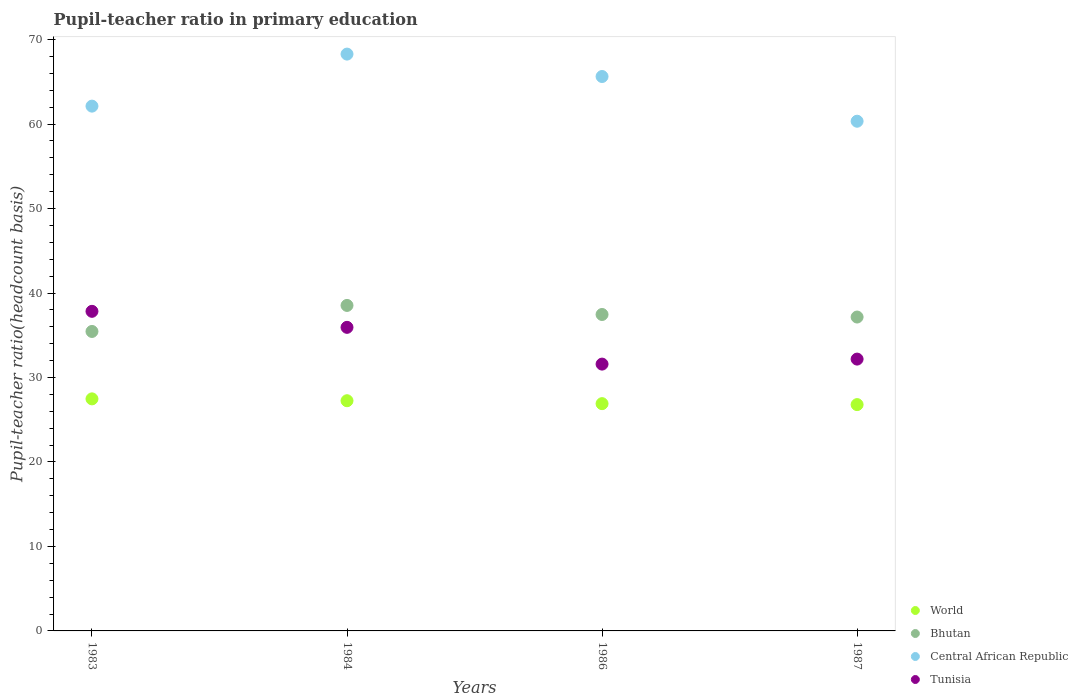What is the pupil-teacher ratio in primary education in Tunisia in 1984?
Provide a short and direct response. 35.94. Across all years, what is the maximum pupil-teacher ratio in primary education in Central African Republic?
Your answer should be compact. 68.29. Across all years, what is the minimum pupil-teacher ratio in primary education in Bhutan?
Your answer should be compact. 35.45. In which year was the pupil-teacher ratio in primary education in World maximum?
Give a very brief answer. 1983. In which year was the pupil-teacher ratio in primary education in World minimum?
Your answer should be compact. 1987. What is the total pupil-teacher ratio in primary education in Tunisia in the graph?
Make the answer very short. 137.54. What is the difference between the pupil-teacher ratio in primary education in Bhutan in 1983 and that in 1984?
Offer a terse response. -3.08. What is the difference between the pupil-teacher ratio in primary education in Tunisia in 1983 and the pupil-teacher ratio in primary education in Central African Republic in 1986?
Keep it short and to the point. -27.8. What is the average pupil-teacher ratio in primary education in Bhutan per year?
Ensure brevity in your answer.  37.15. In the year 1987, what is the difference between the pupil-teacher ratio in primary education in World and pupil-teacher ratio in primary education in Central African Republic?
Give a very brief answer. -33.55. What is the ratio of the pupil-teacher ratio in primary education in Tunisia in 1984 to that in 1986?
Provide a succinct answer. 1.14. Is the pupil-teacher ratio in primary education in World in 1986 less than that in 1987?
Make the answer very short. No. Is the difference between the pupil-teacher ratio in primary education in World in 1984 and 1987 greater than the difference between the pupil-teacher ratio in primary education in Central African Republic in 1984 and 1987?
Provide a succinct answer. No. What is the difference between the highest and the second highest pupil-teacher ratio in primary education in Bhutan?
Make the answer very short. 1.07. What is the difference between the highest and the lowest pupil-teacher ratio in primary education in Bhutan?
Your response must be concise. 3.08. In how many years, is the pupil-teacher ratio in primary education in World greater than the average pupil-teacher ratio in primary education in World taken over all years?
Provide a short and direct response. 2. Is the sum of the pupil-teacher ratio in primary education in World in 1986 and 1987 greater than the maximum pupil-teacher ratio in primary education in Central African Republic across all years?
Offer a very short reply. No. Is it the case that in every year, the sum of the pupil-teacher ratio in primary education in Central African Republic and pupil-teacher ratio in primary education in Bhutan  is greater than the sum of pupil-teacher ratio in primary education in World and pupil-teacher ratio in primary education in Tunisia?
Keep it short and to the point. No. Does the pupil-teacher ratio in primary education in Tunisia monotonically increase over the years?
Make the answer very short. No. What is the difference between two consecutive major ticks on the Y-axis?
Keep it short and to the point. 10. Are the values on the major ticks of Y-axis written in scientific E-notation?
Provide a succinct answer. No. Does the graph contain any zero values?
Provide a short and direct response. No. Does the graph contain grids?
Offer a terse response. No. How many legend labels are there?
Give a very brief answer. 4. How are the legend labels stacked?
Give a very brief answer. Vertical. What is the title of the graph?
Offer a very short reply. Pupil-teacher ratio in primary education. Does "Israel" appear as one of the legend labels in the graph?
Your answer should be very brief. No. What is the label or title of the Y-axis?
Provide a succinct answer. Pupil-teacher ratio(headcount basis). What is the Pupil-teacher ratio(headcount basis) in World in 1983?
Make the answer very short. 27.47. What is the Pupil-teacher ratio(headcount basis) of Bhutan in 1983?
Give a very brief answer. 35.45. What is the Pupil-teacher ratio(headcount basis) in Central African Republic in 1983?
Your answer should be compact. 62.13. What is the Pupil-teacher ratio(headcount basis) in Tunisia in 1983?
Your answer should be very brief. 37.83. What is the Pupil-teacher ratio(headcount basis) of World in 1984?
Your answer should be very brief. 27.25. What is the Pupil-teacher ratio(headcount basis) in Bhutan in 1984?
Make the answer very short. 38.53. What is the Pupil-teacher ratio(headcount basis) of Central African Republic in 1984?
Give a very brief answer. 68.29. What is the Pupil-teacher ratio(headcount basis) of Tunisia in 1984?
Give a very brief answer. 35.94. What is the Pupil-teacher ratio(headcount basis) in World in 1986?
Your answer should be very brief. 26.9. What is the Pupil-teacher ratio(headcount basis) of Bhutan in 1986?
Ensure brevity in your answer.  37.46. What is the Pupil-teacher ratio(headcount basis) in Central African Republic in 1986?
Keep it short and to the point. 65.63. What is the Pupil-teacher ratio(headcount basis) in Tunisia in 1986?
Offer a very short reply. 31.59. What is the Pupil-teacher ratio(headcount basis) in World in 1987?
Give a very brief answer. 26.79. What is the Pupil-teacher ratio(headcount basis) in Bhutan in 1987?
Give a very brief answer. 37.16. What is the Pupil-teacher ratio(headcount basis) of Central African Republic in 1987?
Offer a very short reply. 60.34. What is the Pupil-teacher ratio(headcount basis) of Tunisia in 1987?
Provide a succinct answer. 32.18. Across all years, what is the maximum Pupil-teacher ratio(headcount basis) of World?
Keep it short and to the point. 27.47. Across all years, what is the maximum Pupil-teacher ratio(headcount basis) in Bhutan?
Offer a terse response. 38.53. Across all years, what is the maximum Pupil-teacher ratio(headcount basis) in Central African Republic?
Offer a very short reply. 68.29. Across all years, what is the maximum Pupil-teacher ratio(headcount basis) of Tunisia?
Keep it short and to the point. 37.83. Across all years, what is the minimum Pupil-teacher ratio(headcount basis) of World?
Keep it short and to the point. 26.79. Across all years, what is the minimum Pupil-teacher ratio(headcount basis) of Bhutan?
Give a very brief answer. 35.45. Across all years, what is the minimum Pupil-teacher ratio(headcount basis) of Central African Republic?
Your response must be concise. 60.34. Across all years, what is the minimum Pupil-teacher ratio(headcount basis) in Tunisia?
Provide a succinct answer. 31.59. What is the total Pupil-teacher ratio(headcount basis) of World in the graph?
Your answer should be very brief. 108.42. What is the total Pupil-teacher ratio(headcount basis) in Bhutan in the graph?
Provide a succinct answer. 148.6. What is the total Pupil-teacher ratio(headcount basis) of Central African Republic in the graph?
Provide a succinct answer. 256.38. What is the total Pupil-teacher ratio(headcount basis) in Tunisia in the graph?
Offer a terse response. 137.54. What is the difference between the Pupil-teacher ratio(headcount basis) of World in 1983 and that in 1984?
Offer a very short reply. 0.22. What is the difference between the Pupil-teacher ratio(headcount basis) in Bhutan in 1983 and that in 1984?
Keep it short and to the point. -3.08. What is the difference between the Pupil-teacher ratio(headcount basis) in Central African Republic in 1983 and that in 1984?
Your answer should be very brief. -6.16. What is the difference between the Pupil-teacher ratio(headcount basis) in Tunisia in 1983 and that in 1984?
Your answer should be compact. 1.9. What is the difference between the Pupil-teacher ratio(headcount basis) of World in 1983 and that in 1986?
Your answer should be very brief. 0.57. What is the difference between the Pupil-teacher ratio(headcount basis) of Bhutan in 1983 and that in 1986?
Give a very brief answer. -2.01. What is the difference between the Pupil-teacher ratio(headcount basis) of Central African Republic in 1983 and that in 1986?
Give a very brief answer. -3.51. What is the difference between the Pupil-teacher ratio(headcount basis) in Tunisia in 1983 and that in 1986?
Give a very brief answer. 6.25. What is the difference between the Pupil-teacher ratio(headcount basis) of World in 1983 and that in 1987?
Provide a succinct answer. 0.68. What is the difference between the Pupil-teacher ratio(headcount basis) of Bhutan in 1983 and that in 1987?
Offer a very short reply. -1.71. What is the difference between the Pupil-teacher ratio(headcount basis) in Central African Republic in 1983 and that in 1987?
Your answer should be very brief. 1.79. What is the difference between the Pupil-teacher ratio(headcount basis) of Tunisia in 1983 and that in 1987?
Keep it short and to the point. 5.65. What is the difference between the Pupil-teacher ratio(headcount basis) in World in 1984 and that in 1986?
Give a very brief answer. 0.35. What is the difference between the Pupil-teacher ratio(headcount basis) in Bhutan in 1984 and that in 1986?
Offer a terse response. 1.07. What is the difference between the Pupil-teacher ratio(headcount basis) of Central African Republic in 1984 and that in 1986?
Provide a short and direct response. 2.65. What is the difference between the Pupil-teacher ratio(headcount basis) in Tunisia in 1984 and that in 1986?
Your response must be concise. 4.35. What is the difference between the Pupil-teacher ratio(headcount basis) of World in 1984 and that in 1987?
Your response must be concise. 0.46. What is the difference between the Pupil-teacher ratio(headcount basis) in Bhutan in 1984 and that in 1987?
Offer a terse response. 1.37. What is the difference between the Pupil-teacher ratio(headcount basis) of Central African Republic in 1984 and that in 1987?
Your answer should be compact. 7.95. What is the difference between the Pupil-teacher ratio(headcount basis) in Tunisia in 1984 and that in 1987?
Your answer should be very brief. 3.76. What is the difference between the Pupil-teacher ratio(headcount basis) in World in 1986 and that in 1987?
Give a very brief answer. 0.11. What is the difference between the Pupil-teacher ratio(headcount basis) of Bhutan in 1986 and that in 1987?
Keep it short and to the point. 0.3. What is the difference between the Pupil-teacher ratio(headcount basis) in Central African Republic in 1986 and that in 1987?
Your answer should be compact. 5.29. What is the difference between the Pupil-teacher ratio(headcount basis) in Tunisia in 1986 and that in 1987?
Keep it short and to the point. -0.59. What is the difference between the Pupil-teacher ratio(headcount basis) of World in 1983 and the Pupil-teacher ratio(headcount basis) of Bhutan in 1984?
Give a very brief answer. -11.06. What is the difference between the Pupil-teacher ratio(headcount basis) of World in 1983 and the Pupil-teacher ratio(headcount basis) of Central African Republic in 1984?
Make the answer very short. -40.81. What is the difference between the Pupil-teacher ratio(headcount basis) of World in 1983 and the Pupil-teacher ratio(headcount basis) of Tunisia in 1984?
Keep it short and to the point. -8.47. What is the difference between the Pupil-teacher ratio(headcount basis) of Bhutan in 1983 and the Pupil-teacher ratio(headcount basis) of Central African Republic in 1984?
Ensure brevity in your answer.  -32.83. What is the difference between the Pupil-teacher ratio(headcount basis) of Bhutan in 1983 and the Pupil-teacher ratio(headcount basis) of Tunisia in 1984?
Provide a short and direct response. -0.49. What is the difference between the Pupil-teacher ratio(headcount basis) in Central African Republic in 1983 and the Pupil-teacher ratio(headcount basis) in Tunisia in 1984?
Give a very brief answer. 26.19. What is the difference between the Pupil-teacher ratio(headcount basis) in World in 1983 and the Pupil-teacher ratio(headcount basis) in Bhutan in 1986?
Offer a very short reply. -9.99. What is the difference between the Pupil-teacher ratio(headcount basis) in World in 1983 and the Pupil-teacher ratio(headcount basis) in Central African Republic in 1986?
Provide a short and direct response. -38.16. What is the difference between the Pupil-teacher ratio(headcount basis) in World in 1983 and the Pupil-teacher ratio(headcount basis) in Tunisia in 1986?
Offer a very short reply. -4.12. What is the difference between the Pupil-teacher ratio(headcount basis) in Bhutan in 1983 and the Pupil-teacher ratio(headcount basis) in Central African Republic in 1986?
Keep it short and to the point. -30.18. What is the difference between the Pupil-teacher ratio(headcount basis) in Bhutan in 1983 and the Pupil-teacher ratio(headcount basis) in Tunisia in 1986?
Provide a short and direct response. 3.86. What is the difference between the Pupil-teacher ratio(headcount basis) of Central African Republic in 1983 and the Pupil-teacher ratio(headcount basis) of Tunisia in 1986?
Offer a terse response. 30.54. What is the difference between the Pupil-teacher ratio(headcount basis) of World in 1983 and the Pupil-teacher ratio(headcount basis) of Bhutan in 1987?
Your answer should be very brief. -9.69. What is the difference between the Pupil-teacher ratio(headcount basis) of World in 1983 and the Pupil-teacher ratio(headcount basis) of Central African Republic in 1987?
Ensure brevity in your answer.  -32.87. What is the difference between the Pupil-teacher ratio(headcount basis) in World in 1983 and the Pupil-teacher ratio(headcount basis) in Tunisia in 1987?
Give a very brief answer. -4.71. What is the difference between the Pupil-teacher ratio(headcount basis) in Bhutan in 1983 and the Pupil-teacher ratio(headcount basis) in Central African Republic in 1987?
Offer a very short reply. -24.89. What is the difference between the Pupil-teacher ratio(headcount basis) in Bhutan in 1983 and the Pupil-teacher ratio(headcount basis) in Tunisia in 1987?
Keep it short and to the point. 3.27. What is the difference between the Pupil-teacher ratio(headcount basis) of Central African Republic in 1983 and the Pupil-teacher ratio(headcount basis) of Tunisia in 1987?
Offer a terse response. 29.95. What is the difference between the Pupil-teacher ratio(headcount basis) in World in 1984 and the Pupil-teacher ratio(headcount basis) in Bhutan in 1986?
Your answer should be very brief. -10.21. What is the difference between the Pupil-teacher ratio(headcount basis) of World in 1984 and the Pupil-teacher ratio(headcount basis) of Central African Republic in 1986?
Your answer should be very brief. -38.38. What is the difference between the Pupil-teacher ratio(headcount basis) in World in 1984 and the Pupil-teacher ratio(headcount basis) in Tunisia in 1986?
Ensure brevity in your answer.  -4.34. What is the difference between the Pupil-teacher ratio(headcount basis) in Bhutan in 1984 and the Pupil-teacher ratio(headcount basis) in Central African Republic in 1986?
Provide a short and direct response. -27.1. What is the difference between the Pupil-teacher ratio(headcount basis) of Bhutan in 1984 and the Pupil-teacher ratio(headcount basis) of Tunisia in 1986?
Make the answer very short. 6.95. What is the difference between the Pupil-teacher ratio(headcount basis) of Central African Republic in 1984 and the Pupil-teacher ratio(headcount basis) of Tunisia in 1986?
Offer a very short reply. 36.7. What is the difference between the Pupil-teacher ratio(headcount basis) of World in 1984 and the Pupil-teacher ratio(headcount basis) of Bhutan in 1987?
Provide a short and direct response. -9.91. What is the difference between the Pupil-teacher ratio(headcount basis) of World in 1984 and the Pupil-teacher ratio(headcount basis) of Central African Republic in 1987?
Provide a succinct answer. -33.09. What is the difference between the Pupil-teacher ratio(headcount basis) in World in 1984 and the Pupil-teacher ratio(headcount basis) in Tunisia in 1987?
Provide a succinct answer. -4.93. What is the difference between the Pupil-teacher ratio(headcount basis) of Bhutan in 1984 and the Pupil-teacher ratio(headcount basis) of Central African Republic in 1987?
Keep it short and to the point. -21.81. What is the difference between the Pupil-teacher ratio(headcount basis) in Bhutan in 1984 and the Pupil-teacher ratio(headcount basis) in Tunisia in 1987?
Provide a succinct answer. 6.35. What is the difference between the Pupil-teacher ratio(headcount basis) of Central African Republic in 1984 and the Pupil-teacher ratio(headcount basis) of Tunisia in 1987?
Provide a short and direct response. 36.11. What is the difference between the Pupil-teacher ratio(headcount basis) in World in 1986 and the Pupil-teacher ratio(headcount basis) in Bhutan in 1987?
Offer a terse response. -10.25. What is the difference between the Pupil-teacher ratio(headcount basis) in World in 1986 and the Pupil-teacher ratio(headcount basis) in Central African Republic in 1987?
Make the answer very short. -33.43. What is the difference between the Pupil-teacher ratio(headcount basis) in World in 1986 and the Pupil-teacher ratio(headcount basis) in Tunisia in 1987?
Your response must be concise. -5.27. What is the difference between the Pupil-teacher ratio(headcount basis) in Bhutan in 1986 and the Pupil-teacher ratio(headcount basis) in Central African Republic in 1987?
Offer a terse response. -22.88. What is the difference between the Pupil-teacher ratio(headcount basis) in Bhutan in 1986 and the Pupil-teacher ratio(headcount basis) in Tunisia in 1987?
Make the answer very short. 5.28. What is the difference between the Pupil-teacher ratio(headcount basis) in Central African Republic in 1986 and the Pupil-teacher ratio(headcount basis) in Tunisia in 1987?
Offer a very short reply. 33.45. What is the average Pupil-teacher ratio(headcount basis) in World per year?
Keep it short and to the point. 27.1. What is the average Pupil-teacher ratio(headcount basis) of Bhutan per year?
Keep it short and to the point. 37.15. What is the average Pupil-teacher ratio(headcount basis) of Central African Republic per year?
Ensure brevity in your answer.  64.1. What is the average Pupil-teacher ratio(headcount basis) of Tunisia per year?
Your response must be concise. 34.38. In the year 1983, what is the difference between the Pupil-teacher ratio(headcount basis) in World and Pupil-teacher ratio(headcount basis) in Bhutan?
Give a very brief answer. -7.98. In the year 1983, what is the difference between the Pupil-teacher ratio(headcount basis) of World and Pupil-teacher ratio(headcount basis) of Central African Republic?
Ensure brevity in your answer.  -34.65. In the year 1983, what is the difference between the Pupil-teacher ratio(headcount basis) of World and Pupil-teacher ratio(headcount basis) of Tunisia?
Keep it short and to the point. -10.36. In the year 1983, what is the difference between the Pupil-teacher ratio(headcount basis) in Bhutan and Pupil-teacher ratio(headcount basis) in Central African Republic?
Your answer should be very brief. -26.67. In the year 1983, what is the difference between the Pupil-teacher ratio(headcount basis) in Bhutan and Pupil-teacher ratio(headcount basis) in Tunisia?
Your answer should be compact. -2.38. In the year 1983, what is the difference between the Pupil-teacher ratio(headcount basis) of Central African Republic and Pupil-teacher ratio(headcount basis) of Tunisia?
Provide a succinct answer. 24.29. In the year 1984, what is the difference between the Pupil-teacher ratio(headcount basis) of World and Pupil-teacher ratio(headcount basis) of Bhutan?
Make the answer very short. -11.28. In the year 1984, what is the difference between the Pupil-teacher ratio(headcount basis) in World and Pupil-teacher ratio(headcount basis) in Central African Republic?
Ensure brevity in your answer.  -41.04. In the year 1984, what is the difference between the Pupil-teacher ratio(headcount basis) of World and Pupil-teacher ratio(headcount basis) of Tunisia?
Provide a succinct answer. -8.69. In the year 1984, what is the difference between the Pupil-teacher ratio(headcount basis) in Bhutan and Pupil-teacher ratio(headcount basis) in Central African Republic?
Offer a very short reply. -29.75. In the year 1984, what is the difference between the Pupil-teacher ratio(headcount basis) of Bhutan and Pupil-teacher ratio(headcount basis) of Tunisia?
Your response must be concise. 2.59. In the year 1984, what is the difference between the Pupil-teacher ratio(headcount basis) of Central African Republic and Pupil-teacher ratio(headcount basis) of Tunisia?
Ensure brevity in your answer.  32.35. In the year 1986, what is the difference between the Pupil-teacher ratio(headcount basis) in World and Pupil-teacher ratio(headcount basis) in Bhutan?
Offer a very short reply. -10.56. In the year 1986, what is the difference between the Pupil-teacher ratio(headcount basis) of World and Pupil-teacher ratio(headcount basis) of Central African Republic?
Your answer should be very brief. -38.73. In the year 1986, what is the difference between the Pupil-teacher ratio(headcount basis) of World and Pupil-teacher ratio(headcount basis) of Tunisia?
Your answer should be very brief. -4.68. In the year 1986, what is the difference between the Pupil-teacher ratio(headcount basis) of Bhutan and Pupil-teacher ratio(headcount basis) of Central African Republic?
Your response must be concise. -28.17. In the year 1986, what is the difference between the Pupil-teacher ratio(headcount basis) in Bhutan and Pupil-teacher ratio(headcount basis) in Tunisia?
Provide a succinct answer. 5.87. In the year 1986, what is the difference between the Pupil-teacher ratio(headcount basis) of Central African Republic and Pupil-teacher ratio(headcount basis) of Tunisia?
Offer a terse response. 34.05. In the year 1987, what is the difference between the Pupil-teacher ratio(headcount basis) of World and Pupil-teacher ratio(headcount basis) of Bhutan?
Keep it short and to the point. -10.37. In the year 1987, what is the difference between the Pupil-teacher ratio(headcount basis) of World and Pupil-teacher ratio(headcount basis) of Central African Republic?
Your response must be concise. -33.55. In the year 1987, what is the difference between the Pupil-teacher ratio(headcount basis) of World and Pupil-teacher ratio(headcount basis) of Tunisia?
Keep it short and to the point. -5.39. In the year 1987, what is the difference between the Pupil-teacher ratio(headcount basis) in Bhutan and Pupil-teacher ratio(headcount basis) in Central African Republic?
Your answer should be very brief. -23.18. In the year 1987, what is the difference between the Pupil-teacher ratio(headcount basis) in Bhutan and Pupil-teacher ratio(headcount basis) in Tunisia?
Your answer should be very brief. 4.98. In the year 1987, what is the difference between the Pupil-teacher ratio(headcount basis) in Central African Republic and Pupil-teacher ratio(headcount basis) in Tunisia?
Provide a short and direct response. 28.16. What is the ratio of the Pupil-teacher ratio(headcount basis) of Central African Republic in 1983 to that in 1984?
Provide a succinct answer. 0.91. What is the ratio of the Pupil-teacher ratio(headcount basis) in Tunisia in 1983 to that in 1984?
Keep it short and to the point. 1.05. What is the ratio of the Pupil-teacher ratio(headcount basis) in World in 1983 to that in 1986?
Your response must be concise. 1.02. What is the ratio of the Pupil-teacher ratio(headcount basis) in Bhutan in 1983 to that in 1986?
Your response must be concise. 0.95. What is the ratio of the Pupil-teacher ratio(headcount basis) in Central African Republic in 1983 to that in 1986?
Offer a terse response. 0.95. What is the ratio of the Pupil-teacher ratio(headcount basis) in Tunisia in 1983 to that in 1986?
Your response must be concise. 1.2. What is the ratio of the Pupil-teacher ratio(headcount basis) of World in 1983 to that in 1987?
Keep it short and to the point. 1.03. What is the ratio of the Pupil-teacher ratio(headcount basis) in Bhutan in 1983 to that in 1987?
Offer a terse response. 0.95. What is the ratio of the Pupil-teacher ratio(headcount basis) in Central African Republic in 1983 to that in 1987?
Provide a succinct answer. 1.03. What is the ratio of the Pupil-teacher ratio(headcount basis) in Tunisia in 1983 to that in 1987?
Give a very brief answer. 1.18. What is the ratio of the Pupil-teacher ratio(headcount basis) in World in 1984 to that in 1986?
Your answer should be very brief. 1.01. What is the ratio of the Pupil-teacher ratio(headcount basis) in Bhutan in 1984 to that in 1986?
Ensure brevity in your answer.  1.03. What is the ratio of the Pupil-teacher ratio(headcount basis) in Central African Republic in 1984 to that in 1986?
Ensure brevity in your answer.  1.04. What is the ratio of the Pupil-teacher ratio(headcount basis) in Tunisia in 1984 to that in 1986?
Keep it short and to the point. 1.14. What is the ratio of the Pupil-teacher ratio(headcount basis) of World in 1984 to that in 1987?
Make the answer very short. 1.02. What is the ratio of the Pupil-teacher ratio(headcount basis) of Central African Republic in 1984 to that in 1987?
Your answer should be compact. 1.13. What is the ratio of the Pupil-teacher ratio(headcount basis) in Tunisia in 1984 to that in 1987?
Ensure brevity in your answer.  1.12. What is the ratio of the Pupil-teacher ratio(headcount basis) of World in 1986 to that in 1987?
Give a very brief answer. 1. What is the ratio of the Pupil-teacher ratio(headcount basis) of Central African Republic in 1986 to that in 1987?
Give a very brief answer. 1.09. What is the ratio of the Pupil-teacher ratio(headcount basis) of Tunisia in 1986 to that in 1987?
Your response must be concise. 0.98. What is the difference between the highest and the second highest Pupil-teacher ratio(headcount basis) of World?
Your answer should be compact. 0.22. What is the difference between the highest and the second highest Pupil-teacher ratio(headcount basis) in Bhutan?
Ensure brevity in your answer.  1.07. What is the difference between the highest and the second highest Pupil-teacher ratio(headcount basis) in Central African Republic?
Ensure brevity in your answer.  2.65. What is the difference between the highest and the second highest Pupil-teacher ratio(headcount basis) of Tunisia?
Keep it short and to the point. 1.9. What is the difference between the highest and the lowest Pupil-teacher ratio(headcount basis) of World?
Keep it short and to the point. 0.68. What is the difference between the highest and the lowest Pupil-teacher ratio(headcount basis) in Bhutan?
Make the answer very short. 3.08. What is the difference between the highest and the lowest Pupil-teacher ratio(headcount basis) in Central African Republic?
Offer a very short reply. 7.95. What is the difference between the highest and the lowest Pupil-teacher ratio(headcount basis) in Tunisia?
Your answer should be compact. 6.25. 